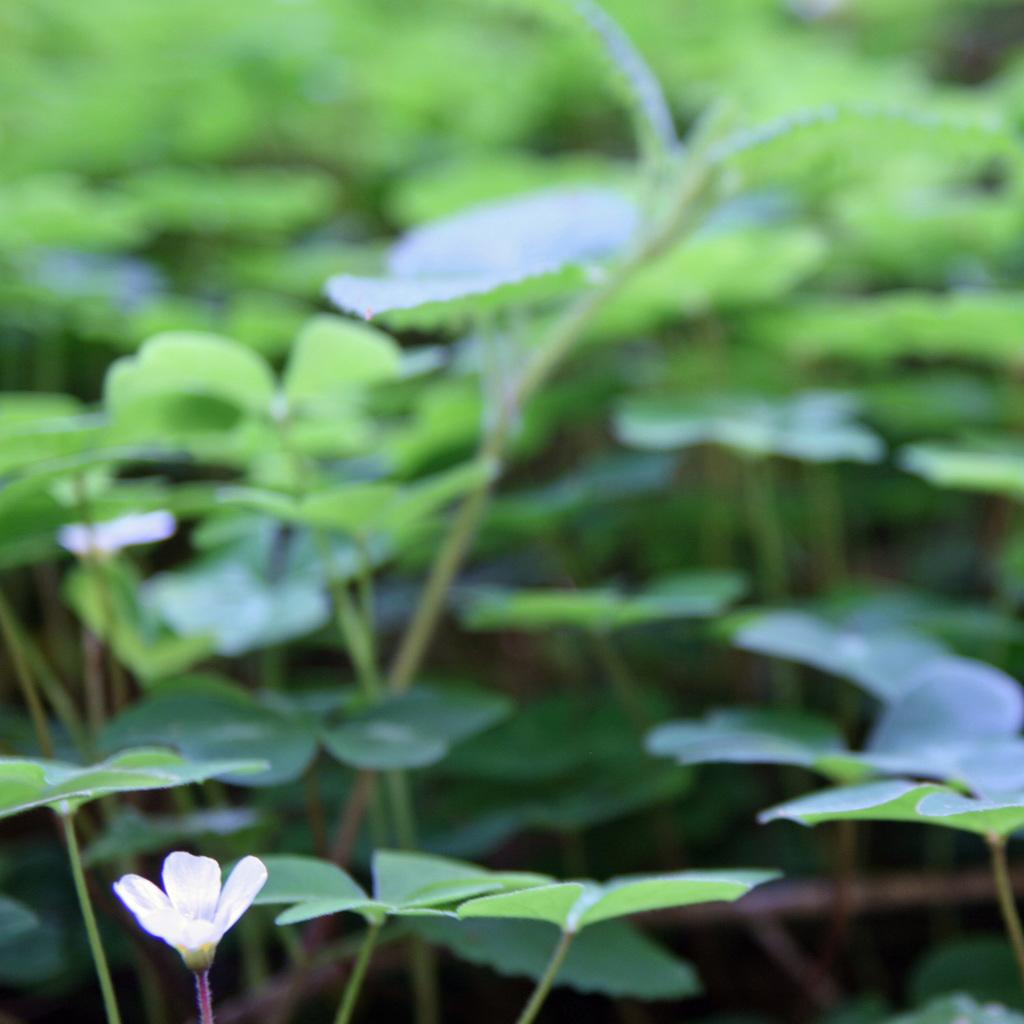What type of vegetation is in the middle of the image? There are green leaves in the middle of the image. What is located at the bottom of the image? There is a small white flower at the bottom of the image. What type of current can be seen flowing through the image? There is no current present in the image; it features green leaves and a small white flower. How many seats are visible in the image? There are no seats present in the image. 